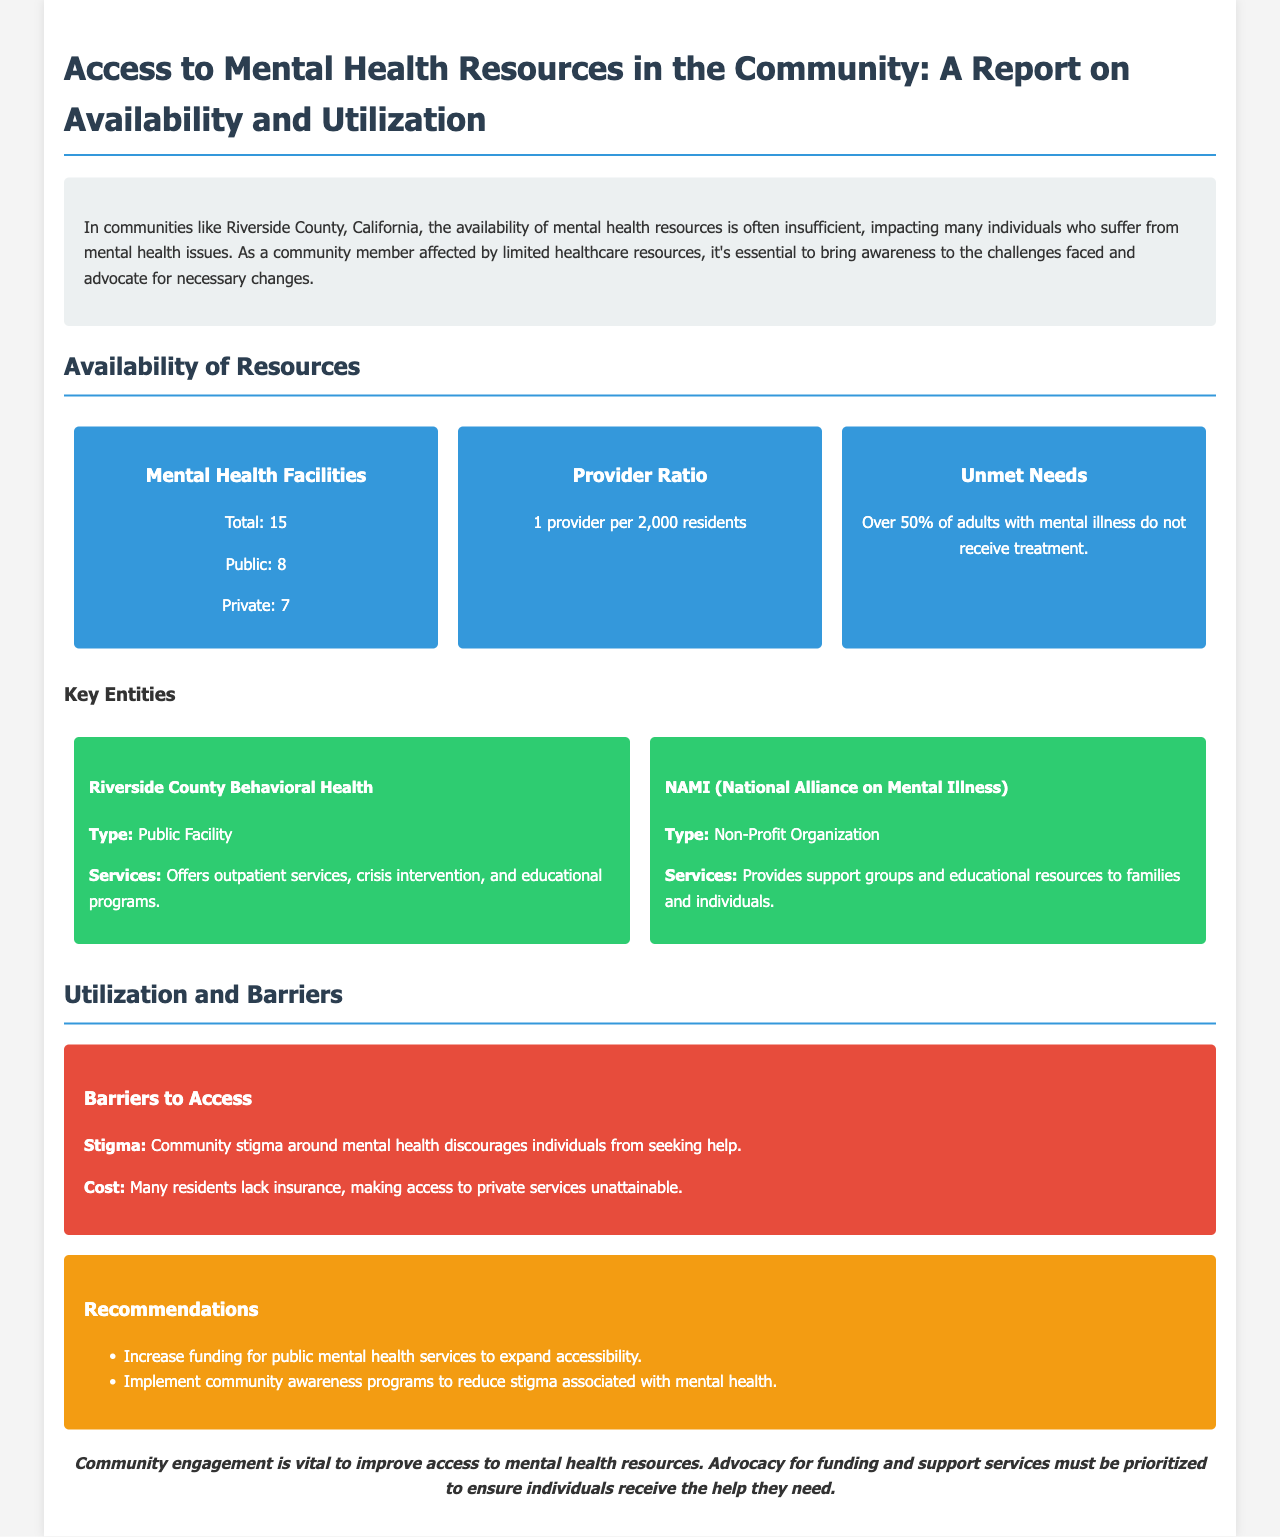What is the total number of mental health facilities? The document states that there are 15 mental health facilities in total.
Answer: 15 What percentage of adults with mental illness do not receive treatment? The report indicates that over 50% of adults with mental illness do not receive treatment.
Answer: Over 50% What type of facility is Riverside County Behavioral Health? The document categorizes Riverside County Behavioral Health as a public facility.
Answer: Public Facility What are the two main barriers to accessing mental health resources mentioned? The document lists stigma and cost as the primary barriers to access.
Answer: Stigma, Cost What is the provider ratio in the community? The report specifies the provider ratio as 1 provider per 2,000 residents.
Answer: 1 provider per 2,000 residents What is one recommendation made in the report? The document recommends increasing funding for public mental health services.
Answer: Increase funding for public mental health services What type of organization is NAMI? The report identifies NAMI as a non-profit organization.
Answer: Non-Profit Organization What does the conclusion emphasize as vital for improving access? The conclusion highlights community engagement as vital for improving access to mental health resources.
Answer: Community engagement 